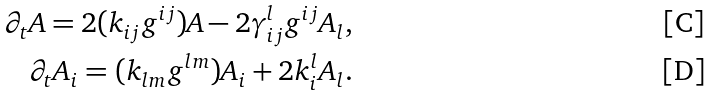Convert formula to latex. <formula><loc_0><loc_0><loc_500><loc_500>\partial _ { t } A = 2 ( k _ { i j } g ^ { i j } ) A - 2 \gamma ^ { l } _ { i j } g ^ { i j } A _ { l } , \\ \partial _ { t } A _ { i } = ( k _ { l m } g ^ { l m } ) A _ { i } + 2 k ^ { l } _ { i } A _ { l } .</formula> 